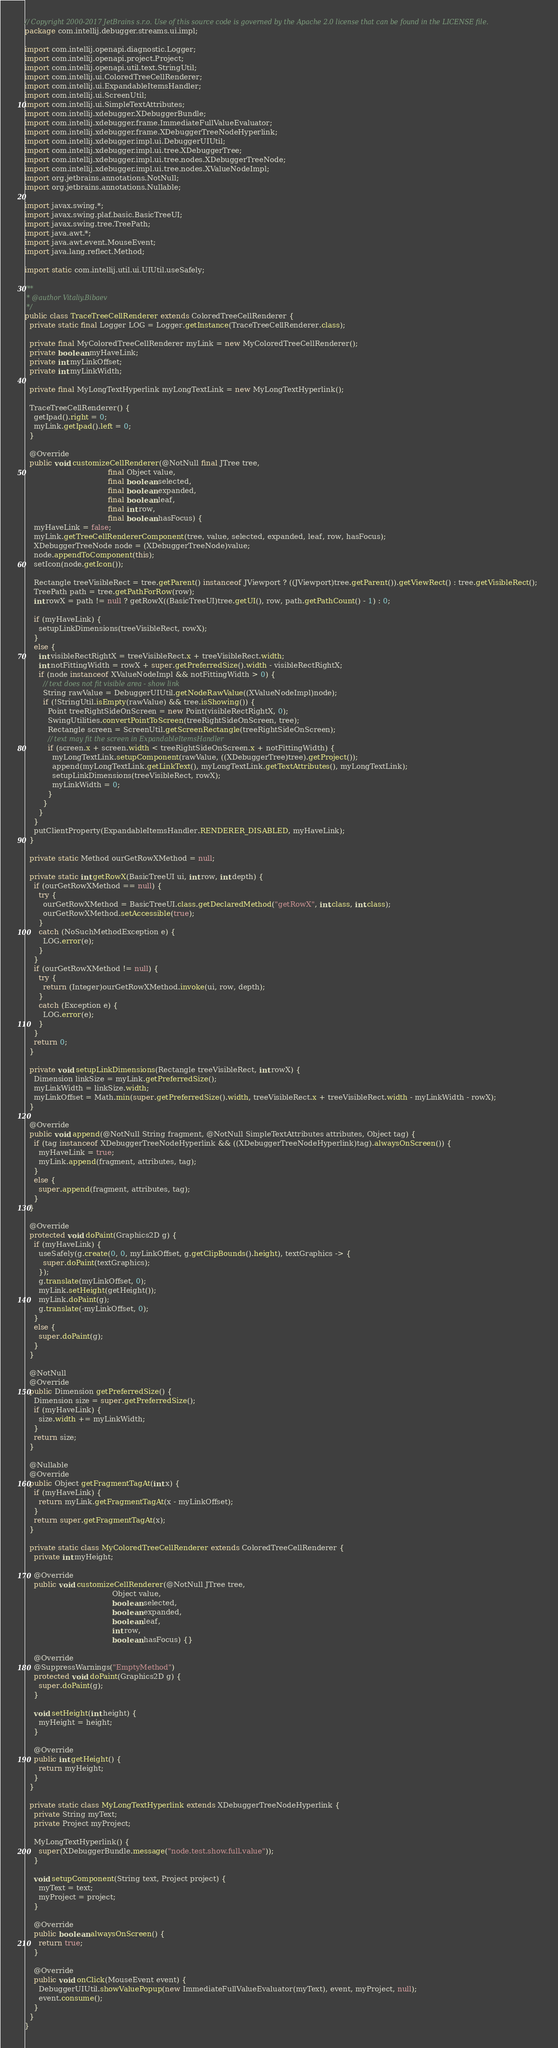Convert code to text. <code><loc_0><loc_0><loc_500><loc_500><_Java_>// Copyright 2000-2017 JetBrains s.r.o. Use of this source code is governed by the Apache 2.0 license that can be found in the LICENSE file.
package com.intellij.debugger.streams.ui.impl;

import com.intellij.openapi.diagnostic.Logger;
import com.intellij.openapi.project.Project;
import com.intellij.openapi.util.text.StringUtil;
import com.intellij.ui.ColoredTreeCellRenderer;
import com.intellij.ui.ExpandableItemsHandler;
import com.intellij.ui.ScreenUtil;
import com.intellij.ui.SimpleTextAttributes;
import com.intellij.xdebugger.XDebuggerBundle;
import com.intellij.xdebugger.frame.ImmediateFullValueEvaluator;
import com.intellij.xdebugger.frame.XDebuggerTreeNodeHyperlink;
import com.intellij.xdebugger.impl.ui.DebuggerUIUtil;
import com.intellij.xdebugger.impl.ui.tree.XDebuggerTree;
import com.intellij.xdebugger.impl.ui.tree.nodes.XDebuggerTreeNode;
import com.intellij.xdebugger.impl.ui.tree.nodes.XValueNodeImpl;
import org.jetbrains.annotations.NotNull;
import org.jetbrains.annotations.Nullable;

import javax.swing.*;
import javax.swing.plaf.basic.BasicTreeUI;
import javax.swing.tree.TreePath;
import java.awt.*;
import java.awt.event.MouseEvent;
import java.lang.reflect.Method;

import static com.intellij.util.ui.UIUtil.useSafely;

/**
 * @author Vitaliy.Bibaev
 */
public class TraceTreeCellRenderer extends ColoredTreeCellRenderer {
  private static final Logger LOG = Logger.getInstance(TraceTreeCellRenderer.class);

  private final MyColoredTreeCellRenderer myLink = new MyColoredTreeCellRenderer();
  private boolean myHaveLink;
  private int myLinkOffset;
  private int myLinkWidth;

  private final MyLongTextHyperlink myLongTextLink = new MyLongTextHyperlink();

  TraceTreeCellRenderer() {
    getIpad().right = 0;
    myLink.getIpad().left = 0;
  }

  @Override
  public void customizeCellRenderer(@NotNull final JTree tree,
                                    final Object value,
                                    final boolean selected,
                                    final boolean expanded,
                                    final boolean leaf,
                                    final int row,
                                    final boolean hasFocus) {
    myHaveLink = false;
    myLink.getTreeCellRendererComponent(tree, value, selected, expanded, leaf, row, hasFocus);
    XDebuggerTreeNode node = (XDebuggerTreeNode)value;
    node.appendToComponent(this);
    setIcon(node.getIcon());

    Rectangle treeVisibleRect = tree.getParent() instanceof JViewport ? ((JViewport)tree.getParent()).getViewRect() : tree.getVisibleRect();
    TreePath path = tree.getPathForRow(row);
    int rowX = path != null ? getRowX((BasicTreeUI)tree.getUI(), row, path.getPathCount() - 1) : 0;

    if (myHaveLink) {
      setupLinkDimensions(treeVisibleRect, rowX);
    }
    else {
      int visibleRectRightX = treeVisibleRect.x + treeVisibleRect.width;
      int notFittingWidth = rowX + super.getPreferredSize().width - visibleRectRightX;
      if (node instanceof XValueNodeImpl && notFittingWidth > 0) {
        // text does not fit visible area - show link
        String rawValue = DebuggerUIUtil.getNodeRawValue((XValueNodeImpl)node);
        if (!StringUtil.isEmpty(rawValue) && tree.isShowing()) {
          Point treeRightSideOnScreen = new Point(visibleRectRightX, 0);
          SwingUtilities.convertPointToScreen(treeRightSideOnScreen, tree);
          Rectangle screen = ScreenUtil.getScreenRectangle(treeRightSideOnScreen);
          // text may fit the screen in ExpandableItemsHandler
          if (screen.x + screen.width < treeRightSideOnScreen.x + notFittingWidth) {
            myLongTextLink.setupComponent(rawValue, ((XDebuggerTree)tree).getProject());
            append(myLongTextLink.getLinkText(), myLongTextLink.getTextAttributes(), myLongTextLink);
            setupLinkDimensions(treeVisibleRect, rowX);
            myLinkWidth = 0;
          }
        }
      }
    }
    putClientProperty(ExpandableItemsHandler.RENDERER_DISABLED, myHaveLink);
  }

  private static Method ourGetRowXMethod = null;

  private static int getRowX(BasicTreeUI ui, int row, int depth) {
    if (ourGetRowXMethod == null) {
      try {
        ourGetRowXMethod = BasicTreeUI.class.getDeclaredMethod("getRowX", int.class, int.class);
        ourGetRowXMethod.setAccessible(true);
      }
      catch (NoSuchMethodException e) {
        LOG.error(e);
      }
    }
    if (ourGetRowXMethod != null) {
      try {
        return (Integer)ourGetRowXMethod.invoke(ui, row, depth);
      }
      catch (Exception e) {
        LOG.error(e);
      }
    }
    return 0;
  }

  private void setupLinkDimensions(Rectangle treeVisibleRect, int rowX) {
    Dimension linkSize = myLink.getPreferredSize();
    myLinkWidth = linkSize.width;
    myLinkOffset = Math.min(super.getPreferredSize().width, treeVisibleRect.x + treeVisibleRect.width - myLinkWidth - rowX);
  }

  @Override
  public void append(@NotNull String fragment, @NotNull SimpleTextAttributes attributes, Object tag) {
    if (tag instanceof XDebuggerTreeNodeHyperlink && ((XDebuggerTreeNodeHyperlink)tag).alwaysOnScreen()) {
      myHaveLink = true;
      myLink.append(fragment, attributes, tag);
    }
    else {
      super.append(fragment, attributes, tag);
    }
  }

  @Override
  protected void doPaint(Graphics2D g) {
    if (myHaveLink) {
      useSafely(g.create(0, 0, myLinkOffset, g.getClipBounds().height), textGraphics -> {
        super.doPaint(textGraphics);
      });
      g.translate(myLinkOffset, 0);
      myLink.setHeight(getHeight());
      myLink.doPaint(g);
      g.translate(-myLinkOffset, 0);
    }
    else {
      super.doPaint(g);
    }
  }

  @NotNull
  @Override
  public Dimension getPreferredSize() {
    Dimension size = super.getPreferredSize();
    if (myHaveLink) {
      size.width += myLinkWidth;
    }
    return size;
  }

  @Nullable
  @Override
  public Object getFragmentTagAt(int x) {
    if (myHaveLink) {
      return myLink.getFragmentTagAt(x - myLinkOffset);
    }
    return super.getFragmentTagAt(x);
  }

  private static class MyColoredTreeCellRenderer extends ColoredTreeCellRenderer {
    private int myHeight;

    @Override
    public void customizeCellRenderer(@NotNull JTree tree,
                                      Object value,
                                      boolean selected,
                                      boolean expanded,
                                      boolean leaf,
                                      int row,
                                      boolean hasFocus) {}

    @Override
    @SuppressWarnings("EmptyMethod")
    protected void doPaint(Graphics2D g) {
      super.doPaint(g);
    }

    void setHeight(int height) {
      myHeight = height;
    }

    @Override
    public int getHeight() {
      return myHeight;
    }
  }

  private static class MyLongTextHyperlink extends XDebuggerTreeNodeHyperlink {
    private String myText;
    private Project myProject;

    MyLongTextHyperlink() {
      super(XDebuggerBundle.message("node.test.show.full.value"));
    }

    void setupComponent(String text, Project project) {
      myText = text;
      myProject = project;
    }

    @Override
    public boolean alwaysOnScreen() {
      return true;
    }

    @Override
    public void onClick(MouseEvent event) {
      DebuggerUIUtil.showValuePopup(new ImmediateFullValueEvaluator(myText), event, myProject, null);
      event.consume();
    }
  }
}
</code> 